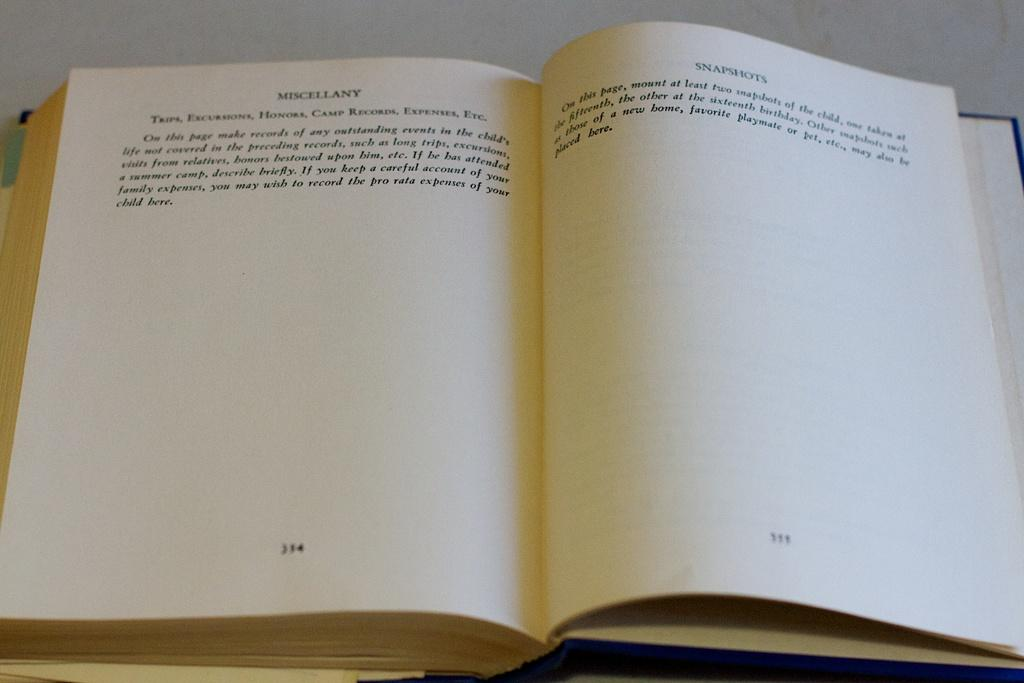Provide a one-sentence caption for the provided image. The second page from this book starts with Snapshots. 